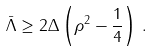<formula> <loc_0><loc_0><loc_500><loc_500>\bar { \Lambda } \geq 2 \Delta \left ( \rho ^ { 2 } - \frac { 1 } { 4 } \right ) \, .</formula> 